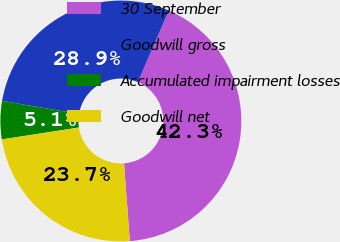<chart> <loc_0><loc_0><loc_500><loc_500><pie_chart><fcel>30 September<fcel>Goodwill gross<fcel>Accumulated impairment losses<fcel>Goodwill net<nl><fcel>42.29%<fcel>28.86%<fcel>5.11%<fcel>23.74%<nl></chart> 